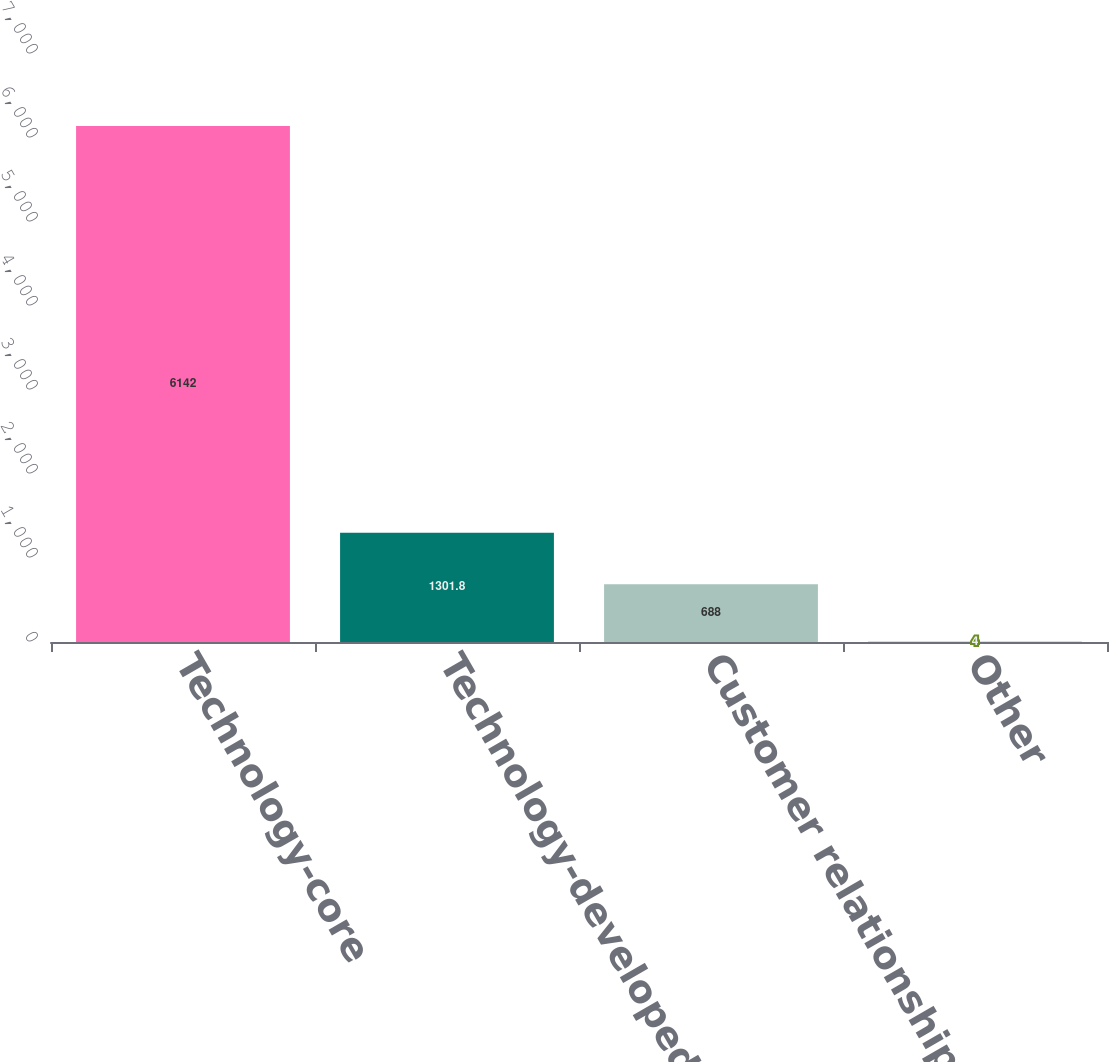Convert chart. <chart><loc_0><loc_0><loc_500><loc_500><bar_chart><fcel>Technology-core<fcel>Technology-developed<fcel>Customer relationships<fcel>Other<nl><fcel>6142<fcel>1301.8<fcel>688<fcel>4<nl></chart> 